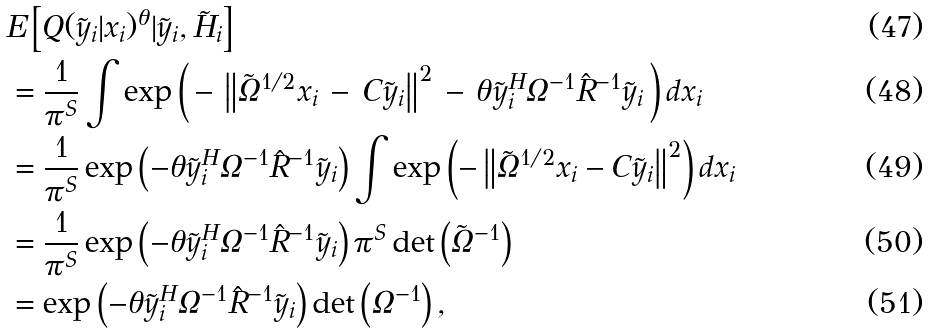Convert formula to latex. <formula><loc_0><loc_0><loc_500><loc_500>& E \left [ Q ( \tilde { y } _ { i } | x _ { i } ) ^ { \theta } | \tilde { y } _ { i } , \tilde { H } _ { i } \right ] \\ & = \frac { 1 } { \pi ^ { S } } \int \exp \left ( \, - \, \left \| \tilde { \Omega } ^ { 1 / 2 } x _ { i } \, - \, C \tilde { y } _ { i } \right \| ^ { 2 } \, - \, \theta \tilde { y } _ { i } ^ { H } \Omega ^ { - 1 } \hat { R } ^ { - 1 } \tilde { y } _ { i } \, \right ) d x _ { i } \\ & = \frac { 1 } { \pi ^ { S } } \exp \left ( - \theta \tilde { y } _ { i } ^ { H } \Omega ^ { - 1 } \hat { R } ^ { - 1 } \tilde { y } _ { i } \right ) \int \exp \left ( - \left \| \tilde { \Omega } ^ { 1 / 2 } x _ { i } - C \tilde { y } _ { i } \right \| ^ { 2 } \right ) d x _ { i } \\ & = \frac { 1 } { \pi ^ { S } } \exp \left ( - \theta \tilde { y } _ { i } ^ { H } \Omega ^ { - 1 } \hat { R } ^ { - 1 } \tilde { y } _ { i } \right ) \pi ^ { S } \det \left ( \tilde { \Omega } ^ { - 1 } \right ) \\ & = \exp \left ( - \theta \tilde { y } _ { i } ^ { H } \Omega ^ { - 1 } \hat { R } ^ { - 1 } \tilde { y } _ { i } \right ) \det \left ( \Omega ^ { - 1 } \right ) ,</formula> 